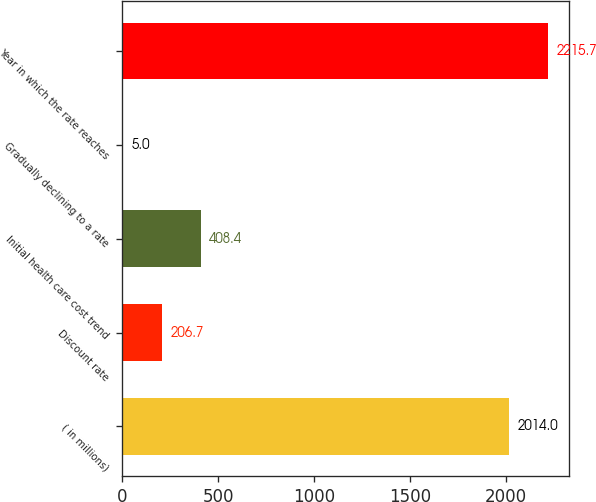<chart> <loc_0><loc_0><loc_500><loc_500><bar_chart><fcel>( in millions)<fcel>Discount rate<fcel>Initial health care cost trend<fcel>Gradually declining to a rate<fcel>Year in which the rate reaches<nl><fcel>2014<fcel>206.7<fcel>408.4<fcel>5<fcel>2215.7<nl></chart> 